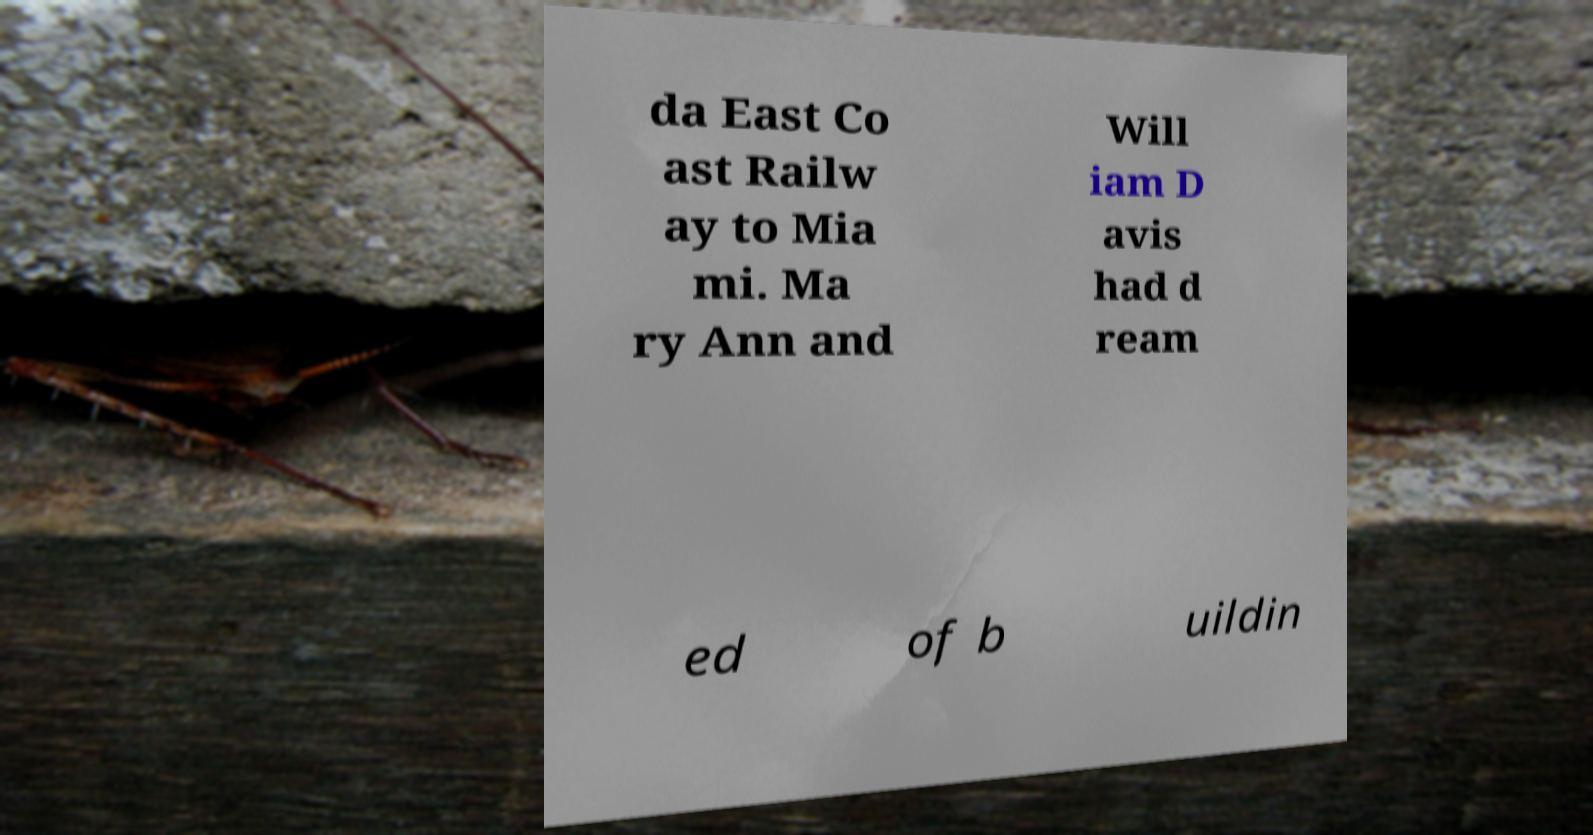Can you accurately transcribe the text from the provided image for me? da East Co ast Railw ay to Mia mi. Ma ry Ann and Will iam D avis had d ream ed of b uildin 